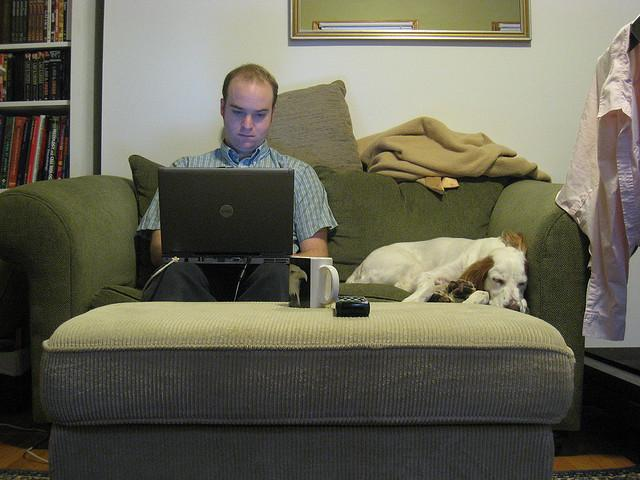What type of potentially harmful light does the laptop screen produce?

Choices:
A) rainbow waves
B) flashing lights
C) uv rays
D) neon lights uv rays 